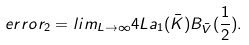<formula> <loc_0><loc_0><loc_500><loc_500>e r r o r _ { 2 } = l i m _ { L \rightarrow \infty } { 4 L } a _ { 1 } ( \bar { K } ) B _ { \bar { V } } ( \frac { 1 } { 2 } ) .</formula> 